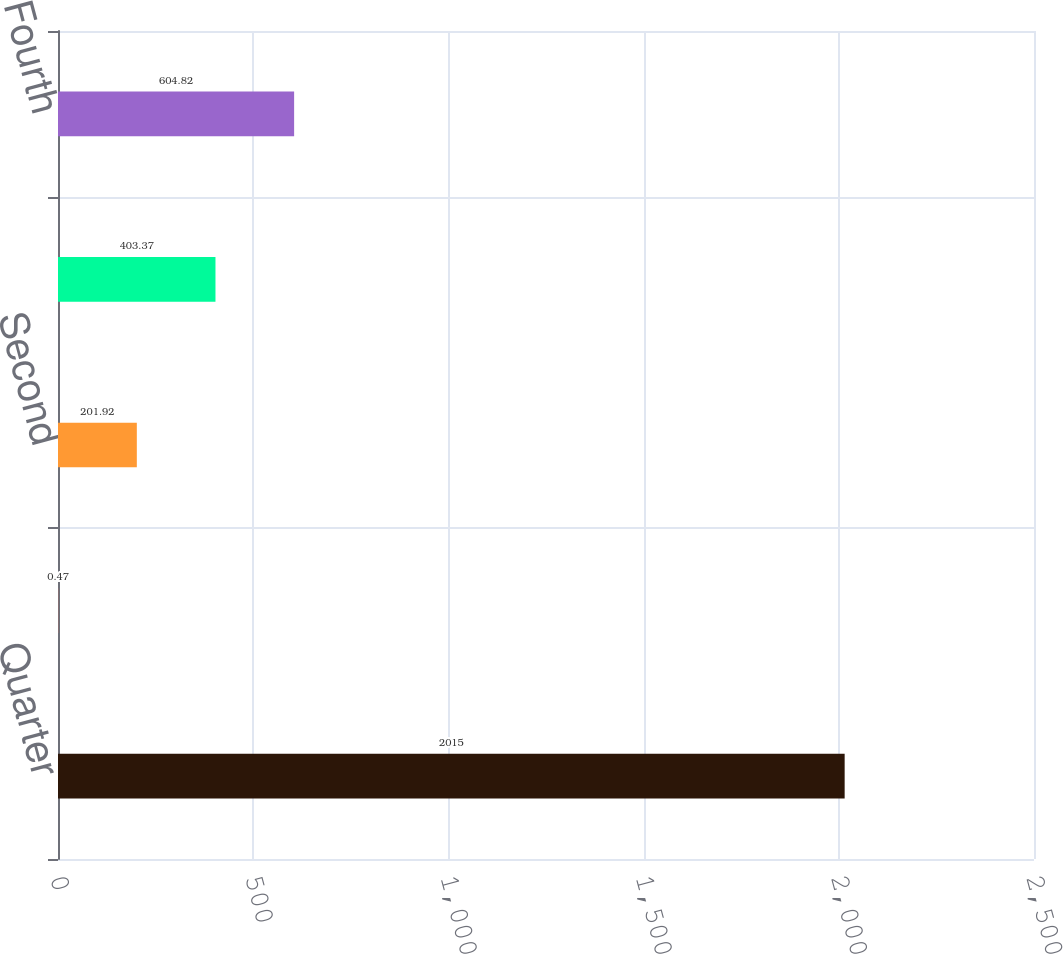Convert chart to OTSL. <chart><loc_0><loc_0><loc_500><loc_500><bar_chart><fcel>Quarter<fcel>First<fcel>Second<fcel>Third<fcel>Fourth<nl><fcel>2015<fcel>0.47<fcel>201.92<fcel>403.37<fcel>604.82<nl></chart> 